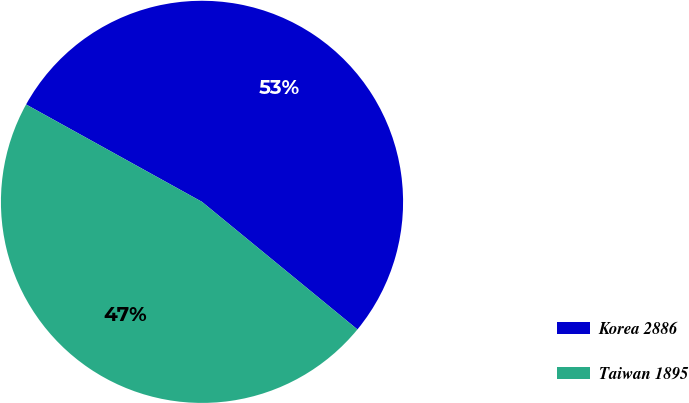Convert chart. <chart><loc_0><loc_0><loc_500><loc_500><pie_chart><fcel>Korea 2886<fcel>Taiwan 1895<nl><fcel>52.89%<fcel>47.11%<nl></chart> 